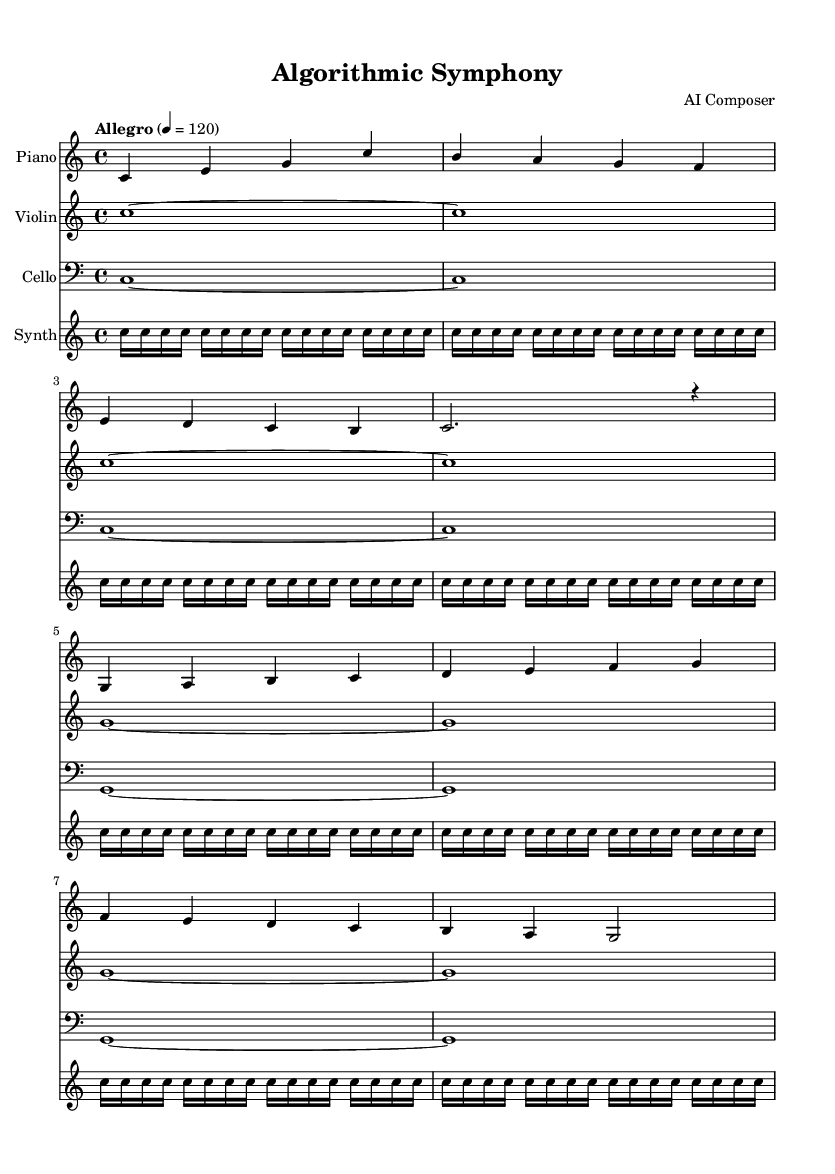What is the key signature of this music? The key signature is C major, which is indicated by the absence of sharps or flats.
Answer: C major What is the time signature of this music? The time signature is 4/4, which means there are four beats in each measure and a quarter note gets one beat. This is seen at the beginning of the score.
Answer: 4/4 What is the tempo marking of this piece? The tempo marking indicates "Allegro", which generally means to play at a fast speed, and is specified with a metronome marking of 120.
Answer: Allegro How many measures are there in the piano part? The piano part consists of 8 measures, which can be counted from the notation provided.
Answer: 8 Which instrument has the longest sustained note? The violin has sustained whole notes throughout the piece, indicated by the notes held for the entire measure, contrasting with other instruments.
Answer: Violin How many times is the note 'C' repeated in the synthesizer part? In the synthesizer part, the note 'C' is repeated a total of 128 times, as indicated by the repeat indication of 32 times for 4 measures.
Answer: 128 What type of musical elements are predominantly used in this piece? The piece incorporates a mix of traditional instruments like piano, violin, and cello, along with a synthesizer, reflecting contemporary classical elements influenced by technology.
Answer: Contemporary classical 